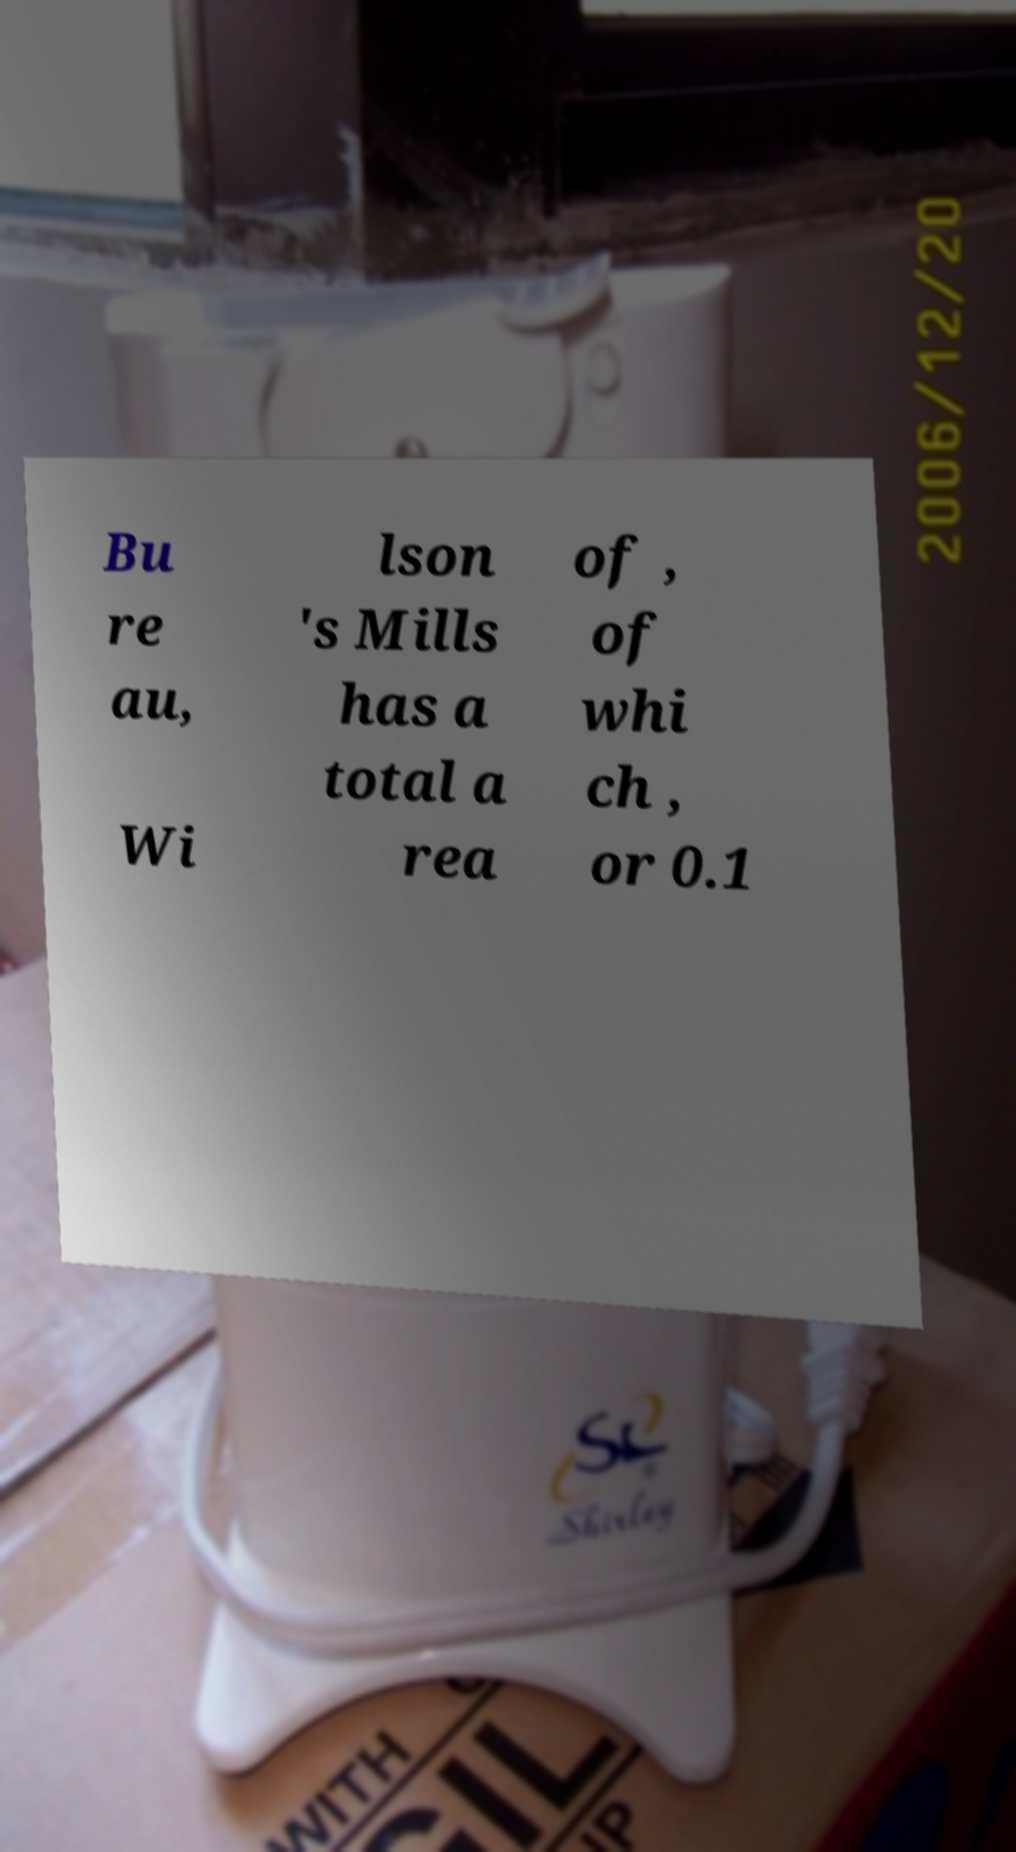Please read and relay the text visible in this image. What does it say? Bu re au, Wi lson 's Mills has a total a rea of , of whi ch , or 0.1 